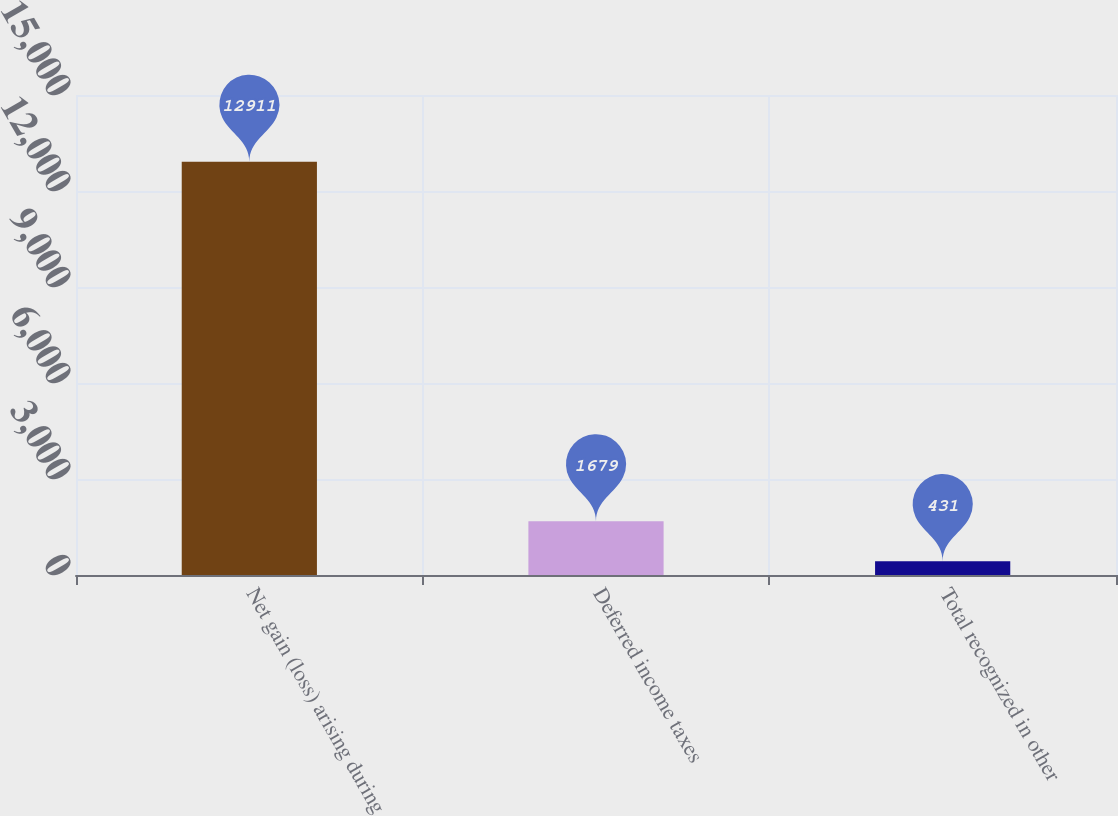<chart> <loc_0><loc_0><loc_500><loc_500><bar_chart><fcel>Net gain (loss) arising during<fcel>Deferred income taxes<fcel>Total recognized in other<nl><fcel>12911<fcel>1679<fcel>431<nl></chart> 